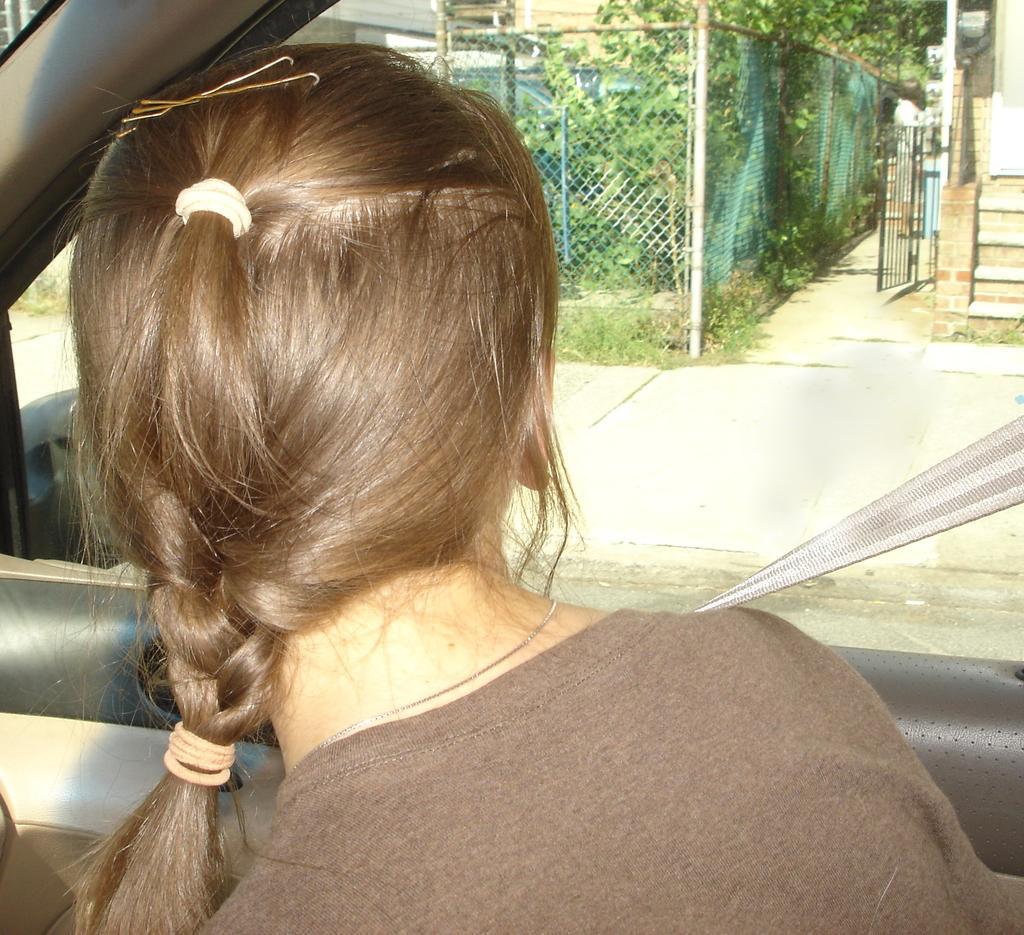How would you summarize this image in a sentence or two? In this image we can see one girl turned backwards and sat in a car. And watching outside the car. And we can see gates and some trees outside the car. 